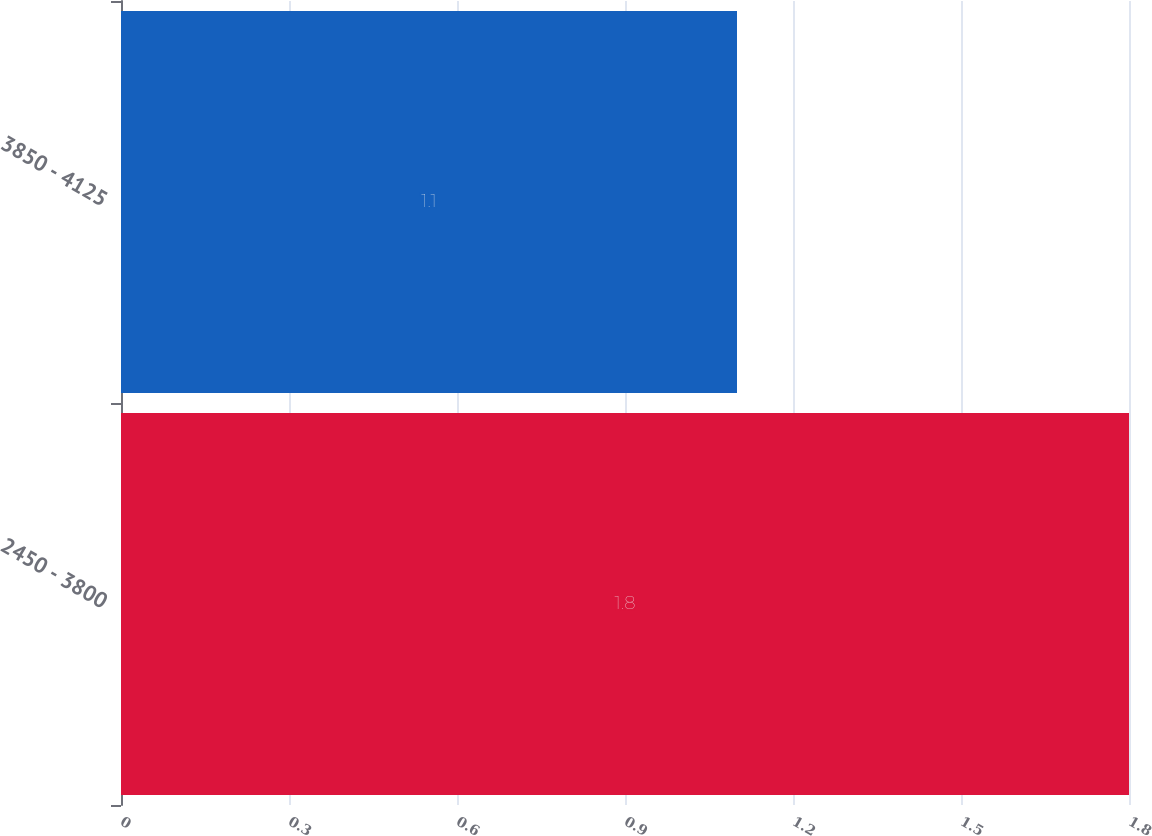<chart> <loc_0><loc_0><loc_500><loc_500><bar_chart><fcel>2450 - 3800<fcel>3850 - 4125<nl><fcel>1.8<fcel>1.1<nl></chart> 